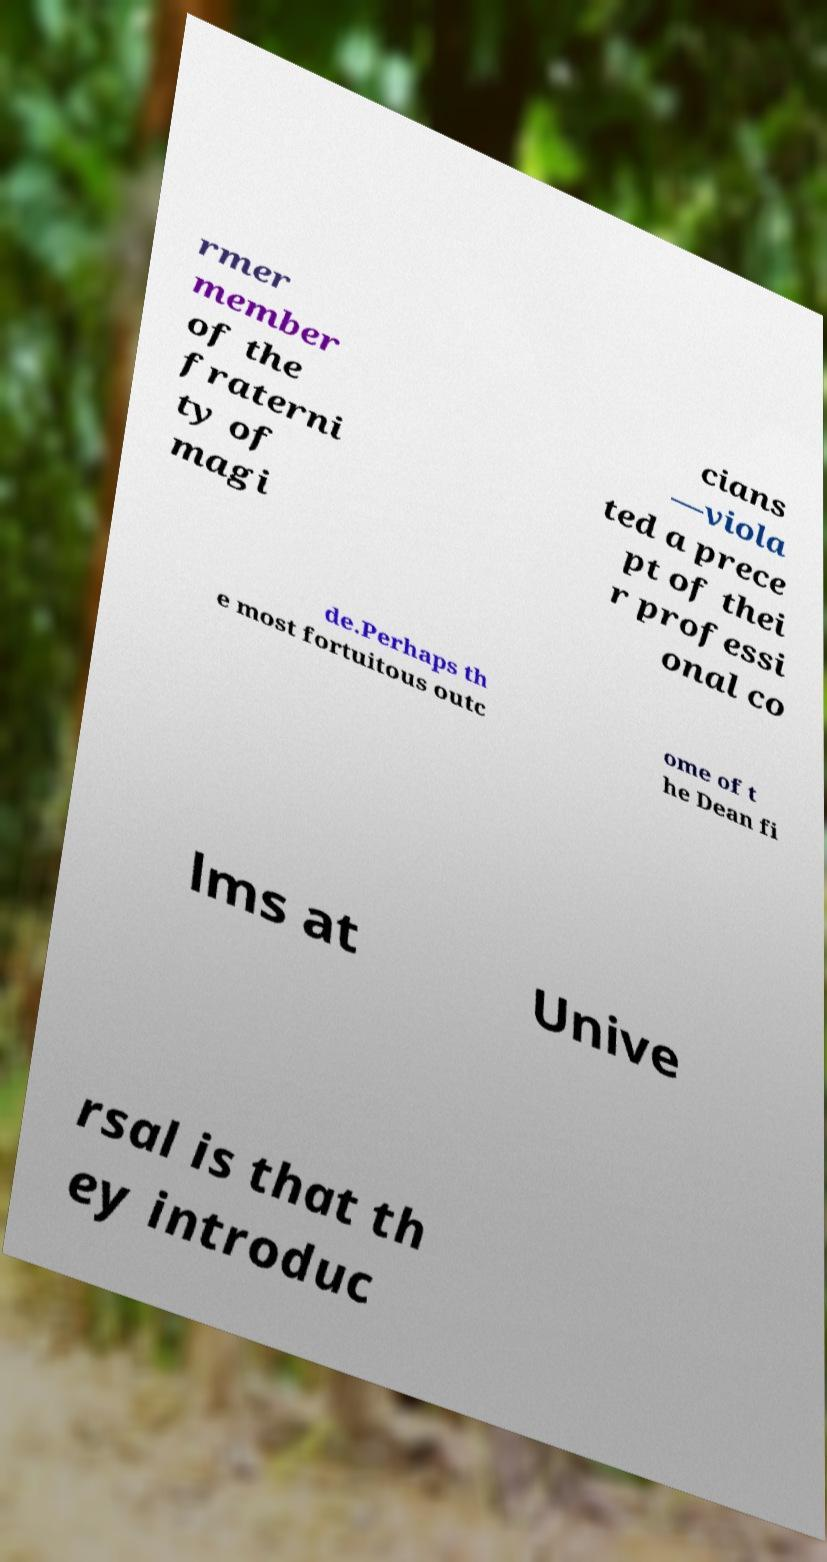There's text embedded in this image that I need extracted. Can you transcribe it verbatim? rmer member of the fraterni ty of magi cians —viola ted a prece pt of thei r professi onal co de.Perhaps th e most fortuitous outc ome of t he Dean fi lms at Unive rsal is that th ey introduc 